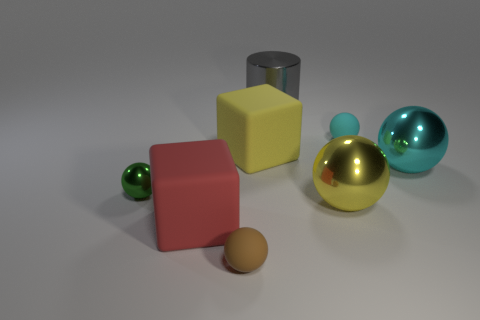How would you describe the lighting in this scene? The lighting in this scene appears to be soft and diffused, coming from above and casting subtle shadows below each object, enhancing their three-dimensional form. 